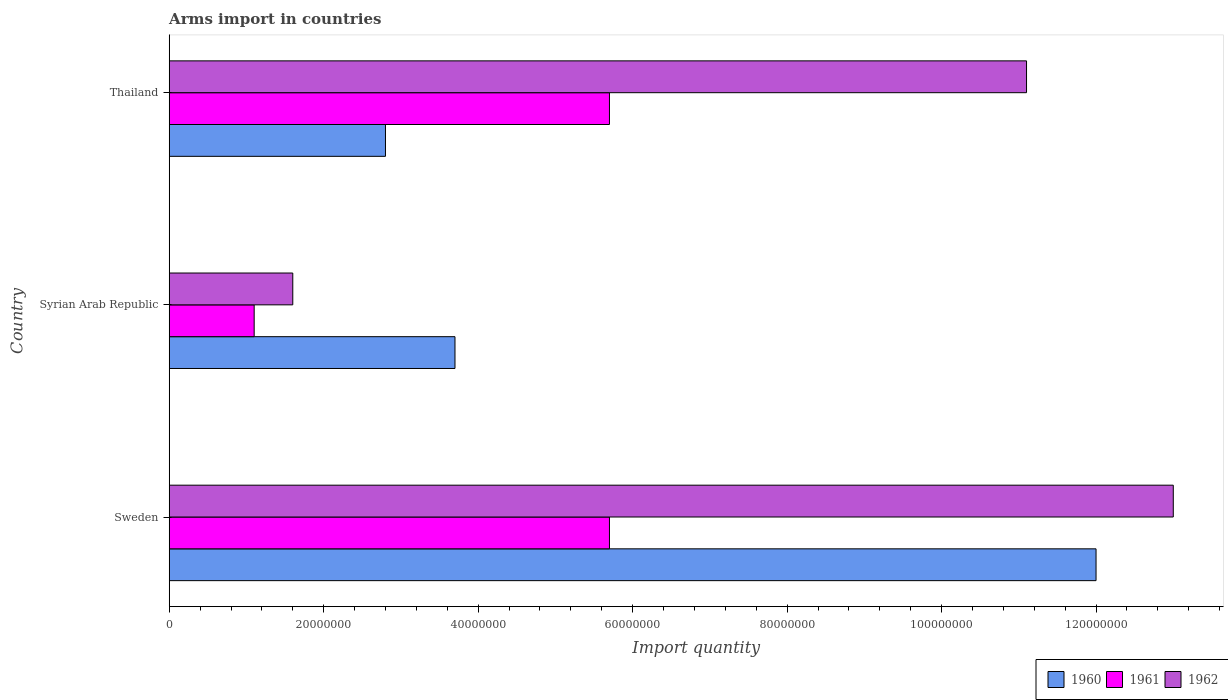How many different coloured bars are there?
Offer a terse response. 3. How many groups of bars are there?
Ensure brevity in your answer.  3. How many bars are there on the 1st tick from the bottom?
Provide a short and direct response. 3. What is the label of the 1st group of bars from the top?
Ensure brevity in your answer.  Thailand. What is the total arms import in 1960 in Thailand?
Keep it short and to the point. 2.80e+07. Across all countries, what is the maximum total arms import in 1962?
Offer a very short reply. 1.30e+08. Across all countries, what is the minimum total arms import in 1960?
Ensure brevity in your answer.  2.80e+07. In which country was the total arms import in 1960 minimum?
Give a very brief answer. Thailand. What is the total total arms import in 1960 in the graph?
Offer a terse response. 1.85e+08. What is the difference between the total arms import in 1960 in Sweden and that in Thailand?
Your answer should be compact. 9.20e+07. What is the difference between the total arms import in 1960 in Thailand and the total arms import in 1962 in Sweden?
Your response must be concise. -1.02e+08. What is the average total arms import in 1961 per country?
Give a very brief answer. 4.17e+07. What is the difference between the total arms import in 1962 and total arms import in 1960 in Thailand?
Keep it short and to the point. 8.30e+07. What is the ratio of the total arms import in 1961 in Sweden to that in Syrian Arab Republic?
Offer a terse response. 5.18. Is the difference between the total arms import in 1962 in Sweden and Syrian Arab Republic greater than the difference between the total arms import in 1960 in Sweden and Syrian Arab Republic?
Give a very brief answer. Yes. What is the difference between the highest and the second highest total arms import in 1960?
Provide a short and direct response. 8.30e+07. What is the difference between the highest and the lowest total arms import in 1961?
Make the answer very short. 4.60e+07. What does the 2nd bar from the bottom in Syrian Arab Republic represents?
Your response must be concise. 1961. Is it the case that in every country, the sum of the total arms import in 1961 and total arms import in 1962 is greater than the total arms import in 1960?
Give a very brief answer. No. How many countries are there in the graph?
Give a very brief answer. 3. What is the difference between two consecutive major ticks on the X-axis?
Offer a terse response. 2.00e+07. Are the values on the major ticks of X-axis written in scientific E-notation?
Keep it short and to the point. No. Does the graph contain grids?
Your response must be concise. No. How many legend labels are there?
Your response must be concise. 3. What is the title of the graph?
Ensure brevity in your answer.  Arms import in countries. What is the label or title of the X-axis?
Provide a succinct answer. Import quantity. What is the label or title of the Y-axis?
Give a very brief answer. Country. What is the Import quantity of 1960 in Sweden?
Offer a terse response. 1.20e+08. What is the Import quantity in 1961 in Sweden?
Give a very brief answer. 5.70e+07. What is the Import quantity in 1962 in Sweden?
Ensure brevity in your answer.  1.30e+08. What is the Import quantity in 1960 in Syrian Arab Republic?
Give a very brief answer. 3.70e+07. What is the Import quantity in 1961 in Syrian Arab Republic?
Your response must be concise. 1.10e+07. What is the Import quantity in 1962 in Syrian Arab Republic?
Your answer should be very brief. 1.60e+07. What is the Import quantity of 1960 in Thailand?
Give a very brief answer. 2.80e+07. What is the Import quantity in 1961 in Thailand?
Provide a succinct answer. 5.70e+07. What is the Import quantity of 1962 in Thailand?
Offer a terse response. 1.11e+08. Across all countries, what is the maximum Import quantity of 1960?
Make the answer very short. 1.20e+08. Across all countries, what is the maximum Import quantity in 1961?
Make the answer very short. 5.70e+07. Across all countries, what is the maximum Import quantity of 1962?
Make the answer very short. 1.30e+08. Across all countries, what is the minimum Import quantity of 1960?
Provide a short and direct response. 2.80e+07. Across all countries, what is the minimum Import quantity in 1961?
Offer a very short reply. 1.10e+07. Across all countries, what is the minimum Import quantity in 1962?
Provide a short and direct response. 1.60e+07. What is the total Import quantity of 1960 in the graph?
Offer a very short reply. 1.85e+08. What is the total Import quantity of 1961 in the graph?
Offer a very short reply. 1.25e+08. What is the total Import quantity of 1962 in the graph?
Keep it short and to the point. 2.57e+08. What is the difference between the Import quantity of 1960 in Sweden and that in Syrian Arab Republic?
Provide a short and direct response. 8.30e+07. What is the difference between the Import quantity of 1961 in Sweden and that in Syrian Arab Republic?
Ensure brevity in your answer.  4.60e+07. What is the difference between the Import quantity in 1962 in Sweden and that in Syrian Arab Republic?
Your answer should be compact. 1.14e+08. What is the difference between the Import quantity of 1960 in Sweden and that in Thailand?
Offer a terse response. 9.20e+07. What is the difference between the Import quantity of 1961 in Sweden and that in Thailand?
Provide a short and direct response. 0. What is the difference between the Import quantity in 1962 in Sweden and that in Thailand?
Your response must be concise. 1.90e+07. What is the difference between the Import quantity of 1960 in Syrian Arab Republic and that in Thailand?
Provide a short and direct response. 9.00e+06. What is the difference between the Import quantity of 1961 in Syrian Arab Republic and that in Thailand?
Keep it short and to the point. -4.60e+07. What is the difference between the Import quantity of 1962 in Syrian Arab Republic and that in Thailand?
Keep it short and to the point. -9.50e+07. What is the difference between the Import quantity in 1960 in Sweden and the Import quantity in 1961 in Syrian Arab Republic?
Your response must be concise. 1.09e+08. What is the difference between the Import quantity of 1960 in Sweden and the Import quantity of 1962 in Syrian Arab Republic?
Provide a succinct answer. 1.04e+08. What is the difference between the Import quantity in 1961 in Sweden and the Import quantity in 1962 in Syrian Arab Republic?
Provide a short and direct response. 4.10e+07. What is the difference between the Import quantity of 1960 in Sweden and the Import quantity of 1961 in Thailand?
Your response must be concise. 6.30e+07. What is the difference between the Import quantity of 1960 in Sweden and the Import quantity of 1962 in Thailand?
Offer a terse response. 9.00e+06. What is the difference between the Import quantity in 1961 in Sweden and the Import quantity in 1962 in Thailand?
Give a very brief answer. -5.40e+07. What is the difference between the Import quantity in 1960 in Syrian Arab Republic and the Import quantity in 1961 in Thailand?
Offer a very short reply. -2.00e+07. What is the difference between the Import quantity in 1960 in Syrian Arab Republic and the Import quantity in 1962 in Thailand?
Give a very brief answer. -7.40e+07. What is the difference between the Import quantity in 1961 in Syrian Arab Republic and the Import quantity in 1962 in Thailand?
Your answer should be compact. -1.00e+08. What is the average Import quantity of 1960 per country?
Your response must be concise. 6.17e+07. What is the average Import quantity of 1961 per country?
Keep it short and to the point. 4.17e+07. What is the average Import quantity of 1962 per country?
Provide a succinct answer. 8.57e+07. What is the difference between the Import quantity in 1960 and Import quantity in 1961 in Sweden?
Offer a terse response. 6.30e+07. What is the difference between the Import quantity in 1960 and Import quantity in 1962 in Sweden?
Keep it short and to the point. -1.00e+07. What is the difference between the Import quantity in 1961 and Import quantity in 1962 in Sweden?
Your answer should be compact. -7.30e+07. What is the difference between the Import quantity in 1960 and Import quantity in 1961 in Syrian Arab Republic?
Offer a very short reply. 2.60e+07. What is the difference between the Import quantity of 1960 and Import quantity of 1962 in Syrian Arab Republic?
Your answer should be very brief. 2.10e+07. What is the difference between the Import quantity in 1961 and Import quantity in 1962 in Syrian Arab Republic?
Offer a terse response. -5.00e+06. What is the difference between the Import quantity in 1960 and Import quantity in 1961 in Thailand?
Provide a short and direct response. -2.90e+07. What is the difference between the Import quantity in 1960 and Import quantity in 1962 in Thailand?
Provide a succinct answer. -8.30e+07. What is the difference between the Import quantity in 1961 and Import quantity in 1962 in Thailand?
Your response must be concise. -5.40e+07. What is the ratio of the Import quantity of 1960 in Sweden to that in Syrian Arab Republic?
Keep it short and to the point. 3.24. What is the ratio of the Import quantity of 1961 in Sweden to that in Syrian Arab Republic?
Your answer should be compact. 5.18. What is the ratio of the Import quantity of 1962 in Sweden to that in Syrian Arab Republic?
Make the answer very short. 8.12. What is the ratio of the Import quantity of 1960 in Sweden to that in Thailand?
Offer a terse response. 4.29. What is the ratio of the Import quantity of 1962 in Sweden to that in Thailand?
Give a very brief answer. 1.17. What is the ratio of the Import quantity in 1960 in Syrian Arab Republic to that in Thailand?
Provide a short and direct response. 1.32. What is the ratio of the Import quantity in 1961 in Syrian Arab Republic to that in Thailand?
Your answer should be compact. 0.19. What is the ratio of the Import quantity of 1962 in Syrian Arab Republic to that in Thailand?
Keep it short and to the point. 0.14. What is the difference between the highest and the second highest Import quantity of 1960?
Your answer should be very brief. 8.30e+07. What is the difference between the highest and the second highest Import quantity of 1961?
Keep it short and to the point. 0. What is the difference between the highest and the second highest Import quantity in 1962?
Make the answer very short. 1.90e+07. What is the difference between the highest and the lowest Import quantity in 1960?
Make the answer very short. 9.20e+07. What is the difference between the highest and the lowest Import quantity in 1961?
Keep it short and to the point. 4.60e+07. What is the difference between the highest and the lowest Import quantity in 1962?
Provide a short and direct response. 1.14e+08. 